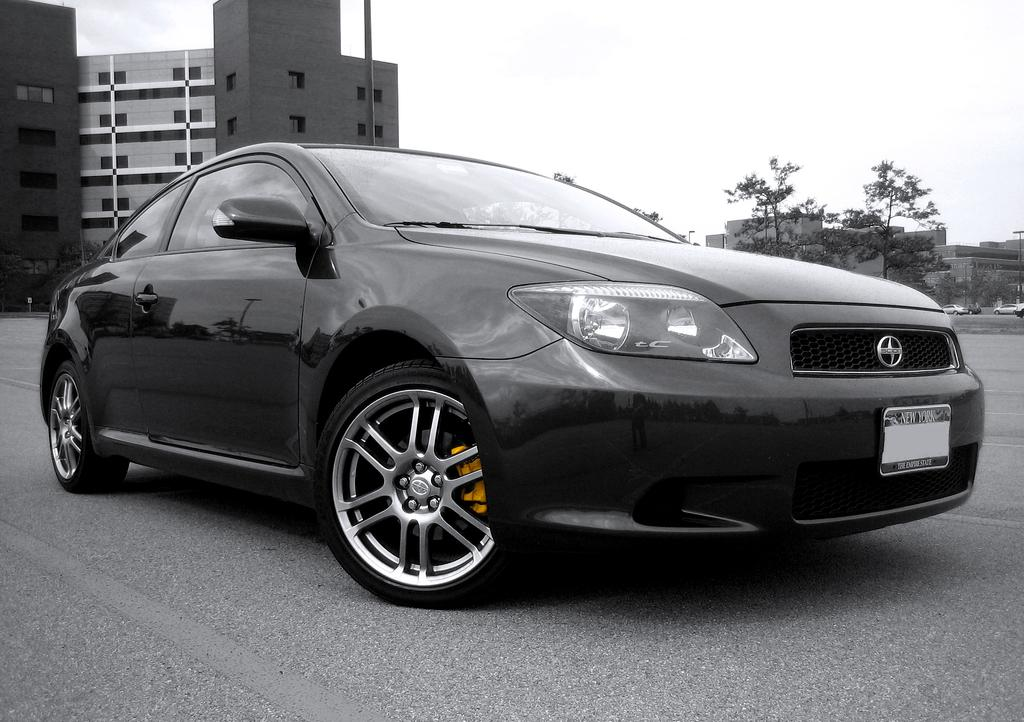What type of structures can be seen in the image? There are buildings in the image. What else can be seen in the image besides buildings? There are poles and trees in the image. Are there any vehicles visible in the image? Yes, motor vehicles are present on the road in the image. What type of jelly can be seen on the poles in the image? There is no jelly present on the poles in the image. Can you describe the discussion taking place between the trees in the image? Trees do not engage in discussions, as they are inanimate objects. 